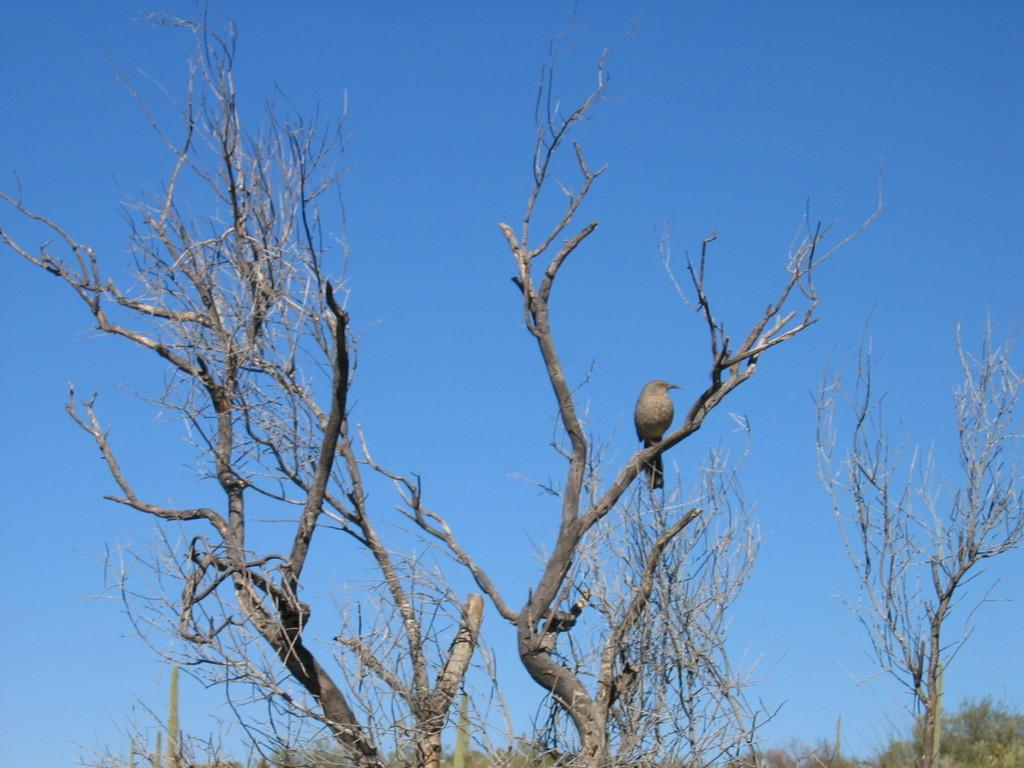What is the bird perched on in the image? There is a bird on a dry tree in the image. What color is the board visible in the image? The board is in grey color. What type of trees can be seen in the background of the image? There are green trees visible in the background. What color is the sky in the image? The sky is blue in color. What type of stove is visible in the image? There is no stove present in the image. 